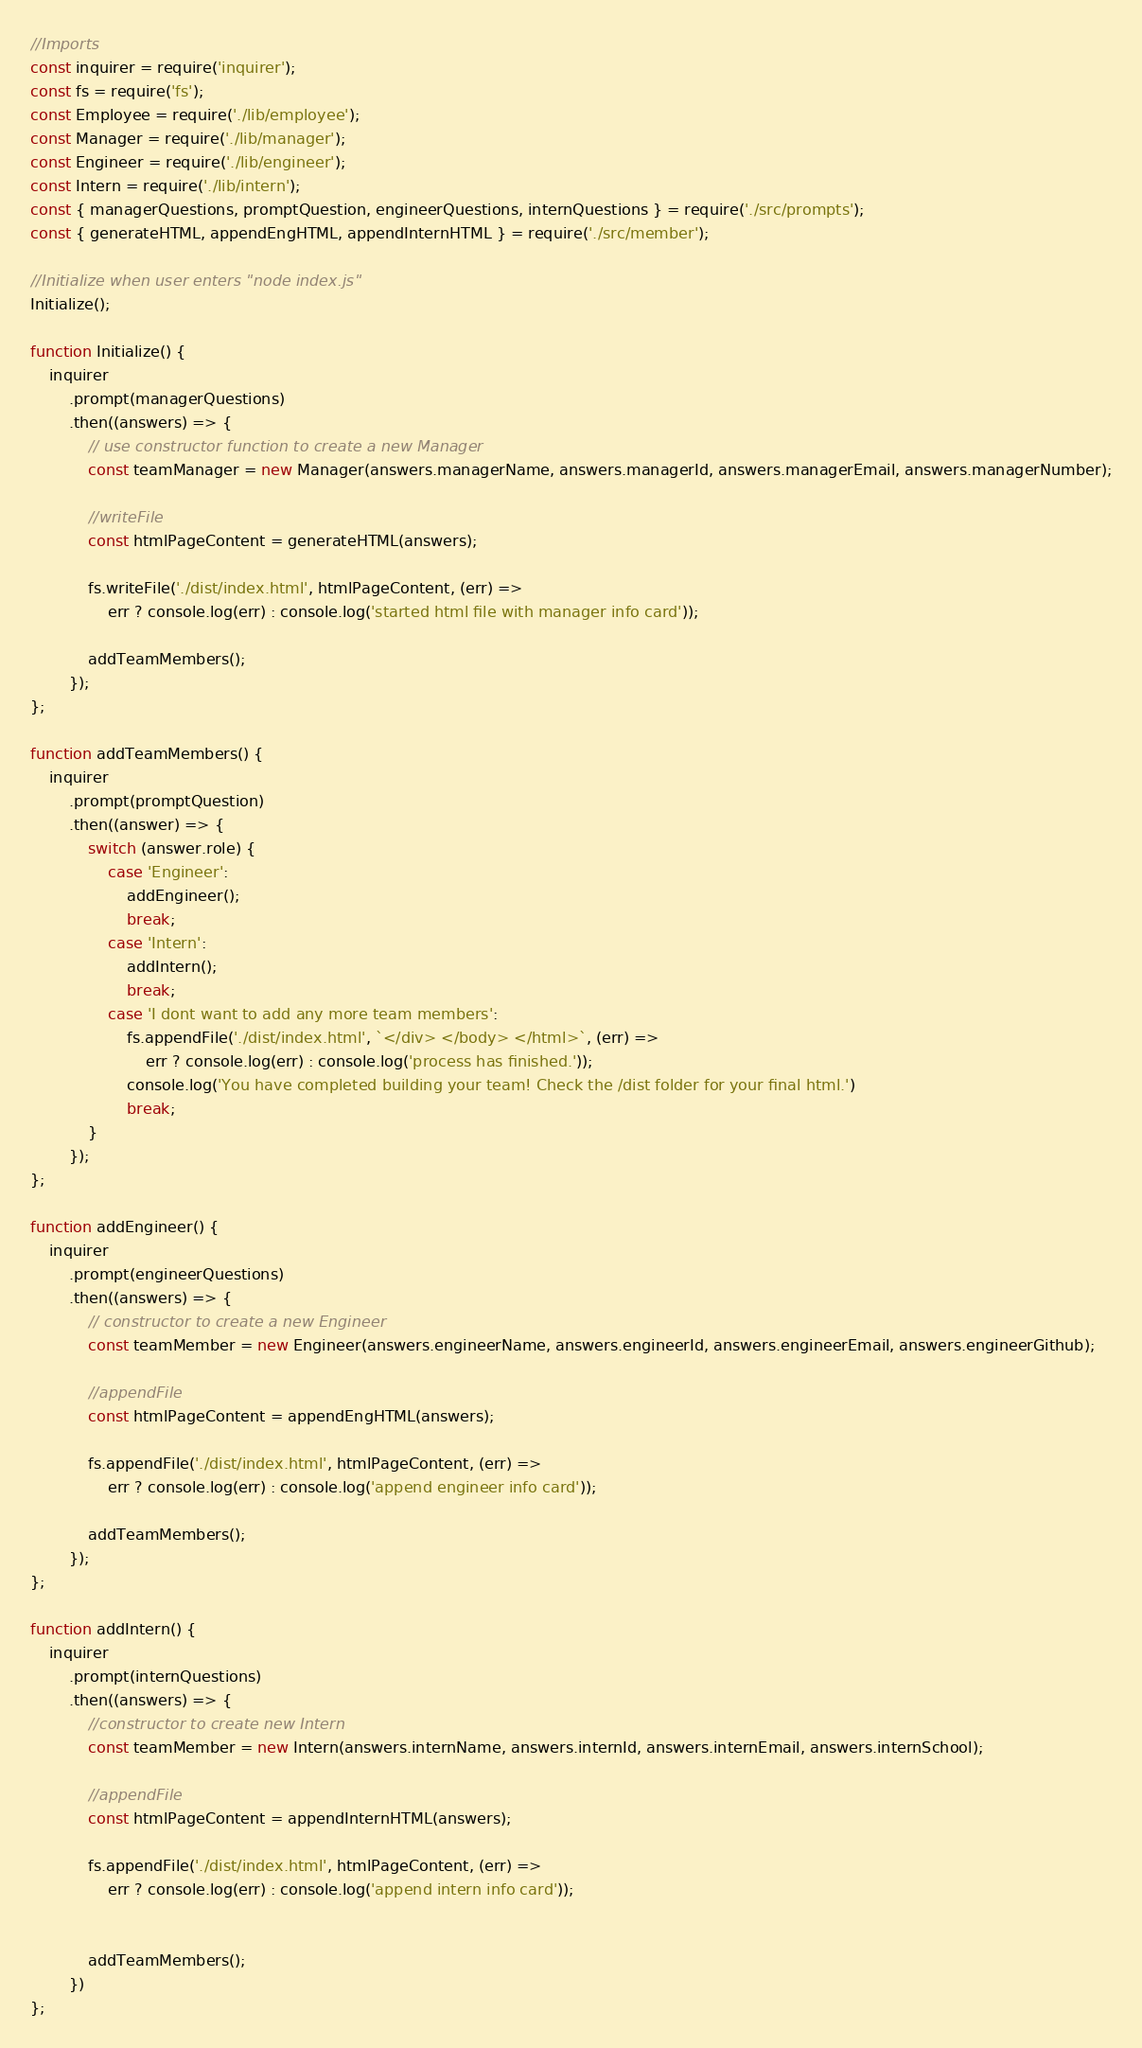Convert code to text. <code><loc_0><loc_0><loc_500><loc_500><_JavaScript_>//Imports
const inquirer = require('inquirer');
const fs = require('fs');
const Employee = require('./lib/employee');
const Manager = require('./lib/manager');
const Engineer = require('./lib/engineer');
const Intern = require('./lib/intern');
const { managerQuestions, promptQuestion, engineerQuestions, internQuestions } = require('./src/prompts');
const { generateHTML, appendEngHTML, appendInternHTML } = require('./src/member');

//Initialize when user enters "node index.js"
Initialize();

function Initialize() {
    inquirer
        .prompt(managerQuestions)
        .then((answers) => {
            // use constructor function to create a new Manager 
            const teamManager = new Manager(answers.managerName, answers.managerId, answers.managerEmail, answers.managerNumber);

            //writeFile
            const htmlPageContent = generateHTML(answers);

            fs.writeFile('./dist/index.html', htmlPageContent, (err) =>
                err ? console.log(err) : console.log('started html file with manager info card'));

            addTeamMembers();
        });
};

function addTeamMembers() {
    inquirer
        .prompt(promptQuestion)
        .then((answer) => {
            switch (answer.role) {
                case 'Engineer':
                    addEngineer();
                    break;
                case 'Intern':
                    addIntern();
                    break;
                case 'I dont want to add any more team members':
                    fs.appendFile('./dist/index.html', `</div> </body> </html>`, (err) =>
                        err ? console.log(err) : console.log('process has finished.'));
                    console.log('You have completed building your team! Check the /dist folder for your final html.')
                    break;
            }
        });
};

function addEngineer() {
    inquirer
        .prompt(engineerQuestions)
        .then((answers) => {
            // constructor to create a new Engineer
            const teamMember = new Engineer(answers.engineerName, answers.engineerId, answers.engineerEmail, answers.engineerGithub);

            //appendFile
            const htmlPageContent = appendEngHTML(answers);

            fs.appendFile('./dist/index.html', htmlPageContent, (err) =>
                err ? console.log(err) : console.log('append engineer info card'));

            addTeamMembers();
        });
};

function addIntern() {
    inquirer
        .prompt(internQuestions)
        .then((answers) => {
            //constructor to create new Intern
            const teamMember = new Intern(answers.internName, answers.internId, answers.internEmail, answers.internSchool);

            //appendFile
            const htmlPageContent = appendInternHTML(answers);

            fs.appendFile('./dist/index.html', htmlPageContent, (err) =>
                err ? console.log(err) : console.log('append intern info card'));


            addTeamMembers();
        })
};
</code> 